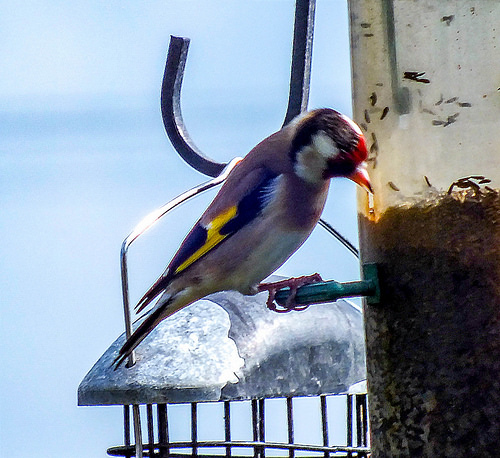<image>
Is there a bird on the bird feeder? Yes. Looking at the image, I can see the bird is positioned on top of the bird feeder, with the bird feeder providing support. 